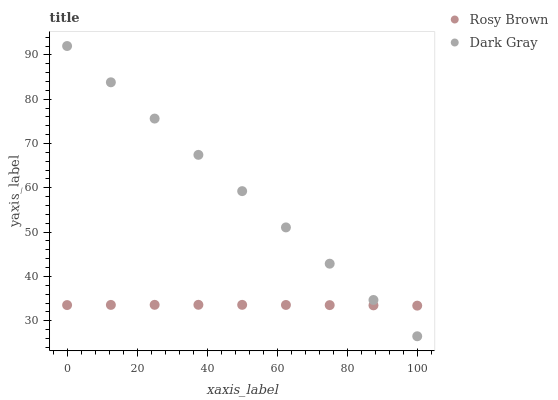Does Rosy Brown have the minimum area under the curve?
Answer yes or no. Yes. Does Dark Gray have the maximum area under the curve?
Answer yes or no. Yes. Does Rosy Brown have the maximum area under the curve?
Answer yes or no. No. Is Dark Gray the smoothest?
Answer yes or no. Yes. Is Rosy Brown the roughest?
Answer yes or no. Yes. Is Rosy Brown the smoothest?
Answer yes or no. No. Does Dark Gray have the lowest value?
Answer yes or no. Yes. Does Rosy Brown have the lowest value?
Answer yes or no. No. Does Dark Gray have the highest value?
Answer yes or no. Yes. Does Rosy Brown have the highest value?
Answer yes or no. No. Does Dark Gray intersect Rosy Brown?
Answer yes or no. Yes. Is Dark Gray less than Rosy Brown?
Answer yes or no. No. Is Dark Gray greater than Rosy Brown?
Answer yes or no. No. 